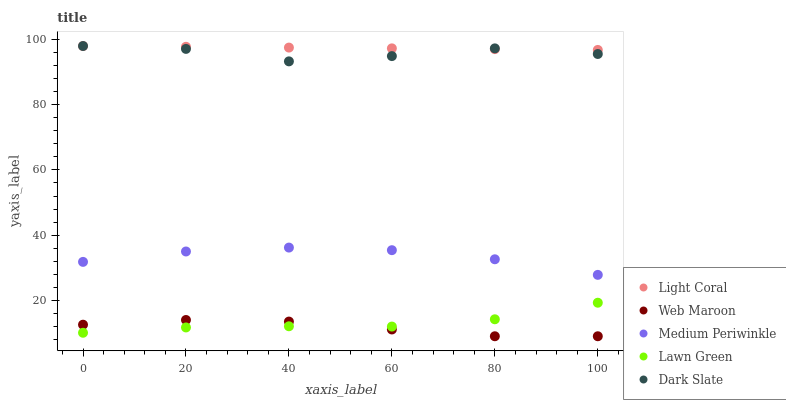Does Web Maroon have the minimum area under the curve?
Answer yes or no. Yes. Does Light Coral have the maximum area under the curve?
Answer yes or no. Yes. Does Medium Periwinkle have the minimum area under the curve?
Answer yes or no. No. Does Medium Periwinkle have the maximum area under the curve?
Answer yes or no. No. Is Light Coral the smoothest?
Answer yes or no. Yes. Is Dark Slate the roughest?
Answer yes or no. Yes. Is Medium Periwinkle the smoothest?
Answer yes or no. No. Is Medium Periwinkle the roughest?
Answer yes or no. No. Does Web Maroon have the lowest value?
Answer yes or no. Yes. Does Medium Periwinkle have the lowest value?
Answer yes or no. No. Does Dark Slate have the highest value?
Answer yes or no. Yes. Does Medium Periwinkle have the highest value?
Answer yes or no. No. Is Lawn Green less than Medium Periwinkle?
Answer yes or no. Yes. Is Light Coral greater than Web Maroon?
Answer yes or no. Yes. Does Web Maroon intersect Lawn Green?
Answer yes or no. Yes. Is Web Maroon less than Lawn Green?
Answer yes or no. No. Is Web Maroon greater than Lawn Green?
Answer yes or no. No. Does Lawn Green intersect Medium Periwinkle?
Answer yes or no. No. 